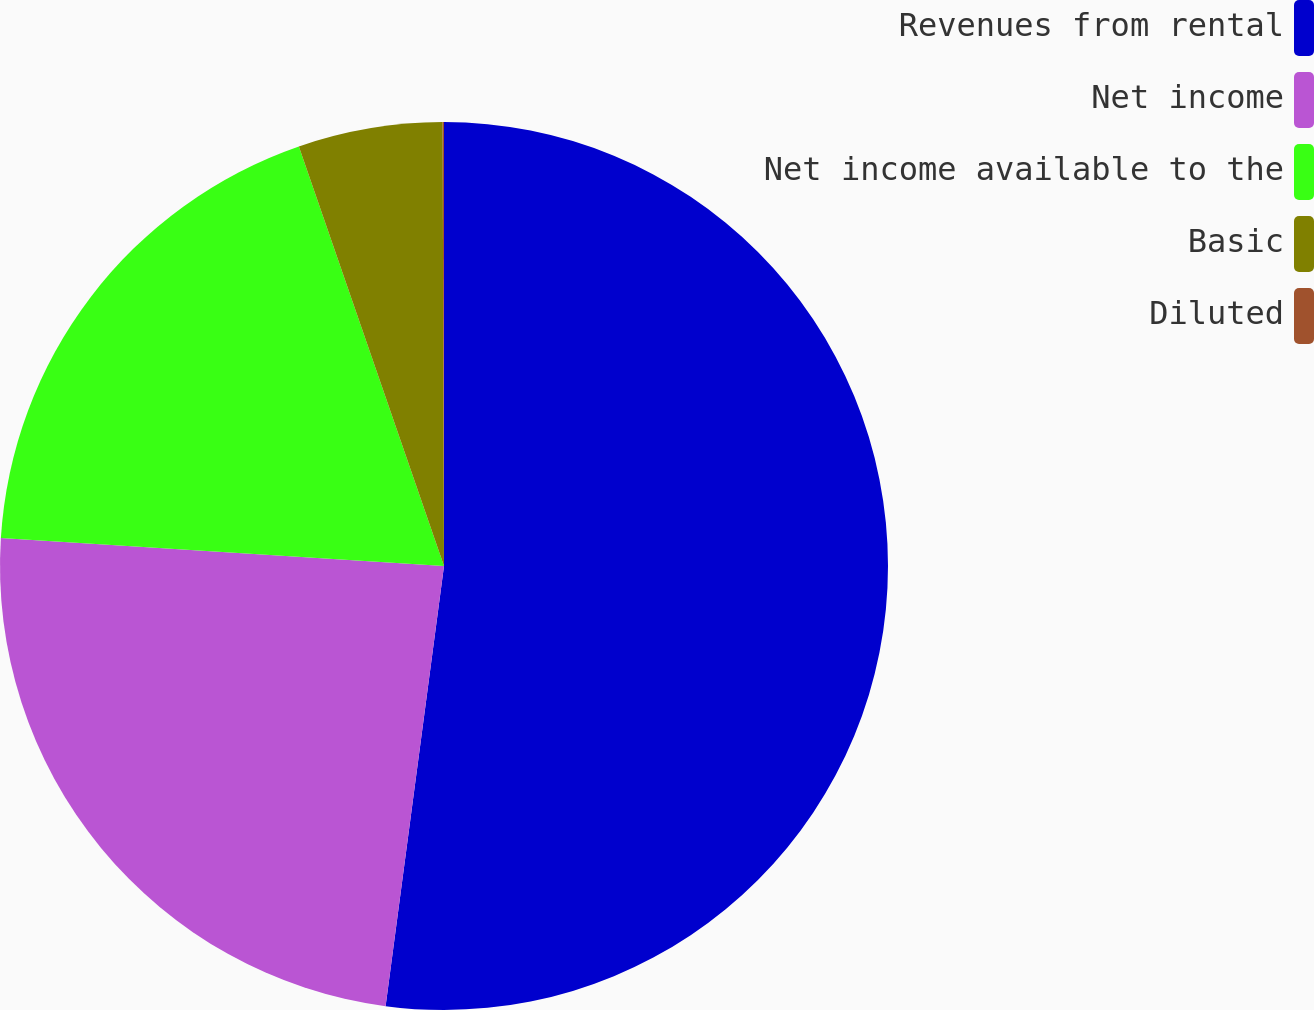Convert chart to OTSL. <chart><loc_0><loc_0><loc_500><loc_500><pie_chart><fcel>Revenues from rental<fcel>Net income<fcel>Net income available to the<fcel>Basic<fcel>Diluted<nl><fcel>52.1%<fcel>23.9%<fcel>18.7%<fcel>5.25%<fcel>0.05%<nl></chart> 